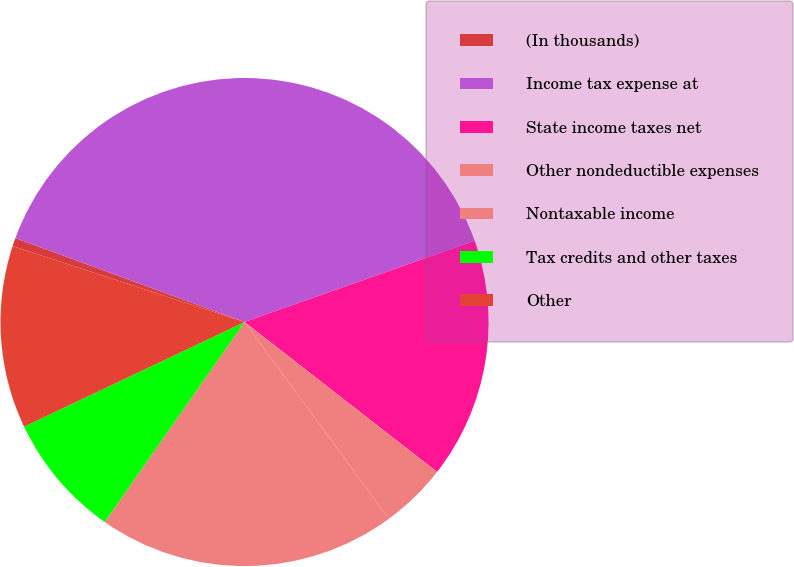<chart> <loc_0><loc_0><loc_500><loc_500><pie_chart><fcel>(In thousands)<fcel>Income tax expense at<fcel>State income taxes net<fcel>Other nondeductible expenses<fcel>Nontaxable income<fcel>Tax credits and other taxes<fcel>Other<nl><fcel>0.55%<fcel>39.01%<fcel>15.93%<fcel>4.4%<fcel>19.78%<fcel>8.24%<fcel>12.09%<nl></chart> 